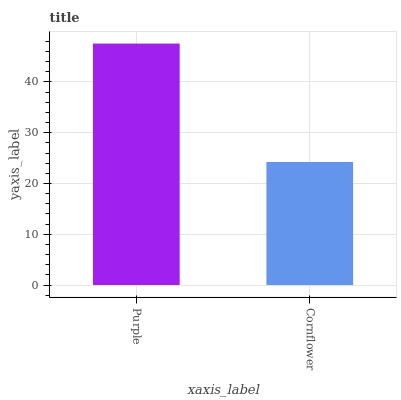Is Cornflower the minimum?
Answer yes or no. Yes. Is Purple the maximum?
Answer yes or no. Yes. Is Cornflower the maximum?
Answer yes or no. No. Is Purple greater than Cornflower?
Answer yes or no. Yes. Is Cornflower less than Purple?
Answer yes or no. Yes. Is Cornflower greater than Purple?
Answer yes or no. No. Is Purple less than Cornflower?
Answer yes or no. No. Is Purple the high median?
Answer yes or no. Yes. Is Cornflower the low median?
Answer yes or no. Yes. Is Cornflower the high median?
Answer yes or no. No. Is Purple the low median?
Answer yes or no. No. 